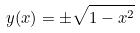<formula> <loc_0><loc_0><loc_500><loc_500>y ( x ) = \pm \sqrt { 1 - x ^ { 2 } }</formula> 